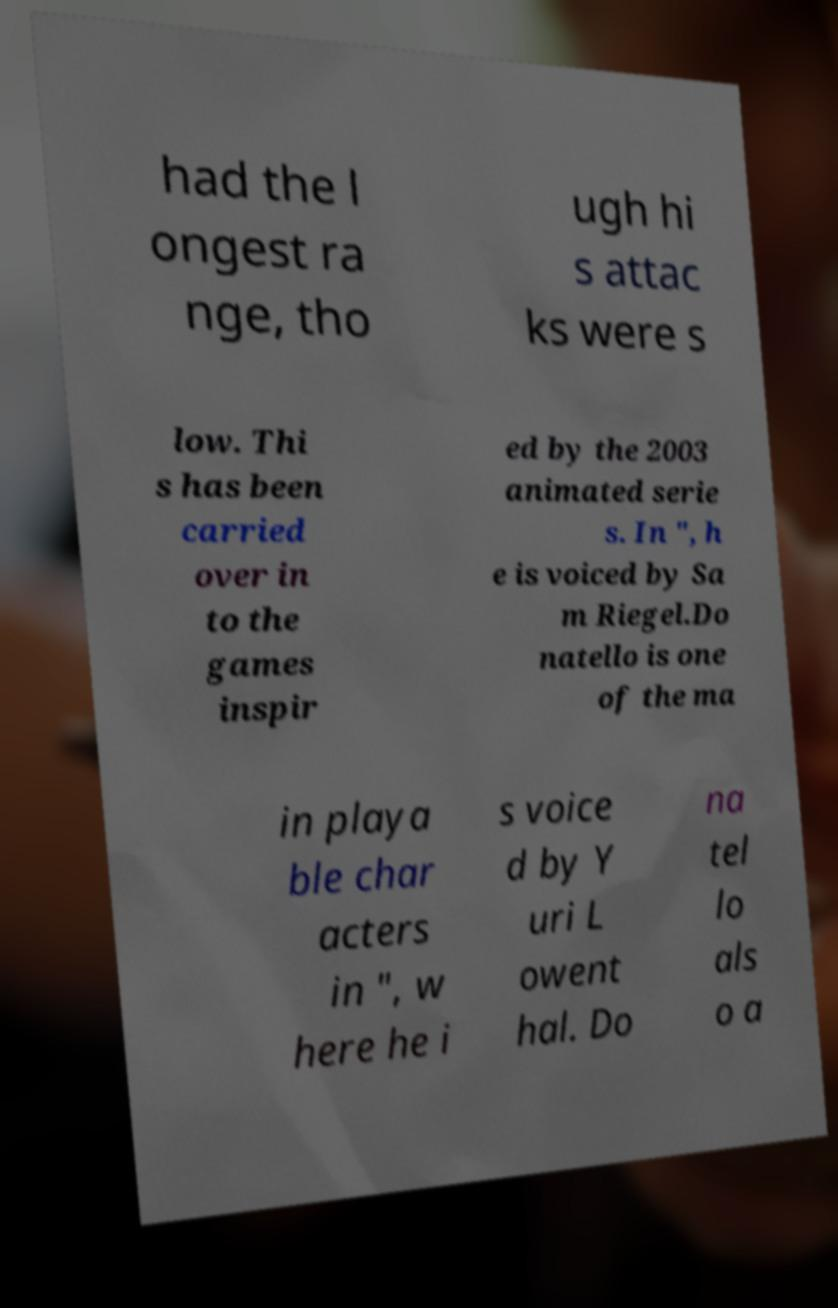Could you extract and type out the text from this image? had the l ongest ra nge, tho ugh hi s attac ks were s low. Thi s has been carried over in to the games inspir ed by the 2003 animated serie s. In ", h e is voiced by Sa m Riegel.Do natello is one of the ma in playa ble char acters in ", w here he i s voice d by Y uri L owent hal. Do na tel lo als o a 